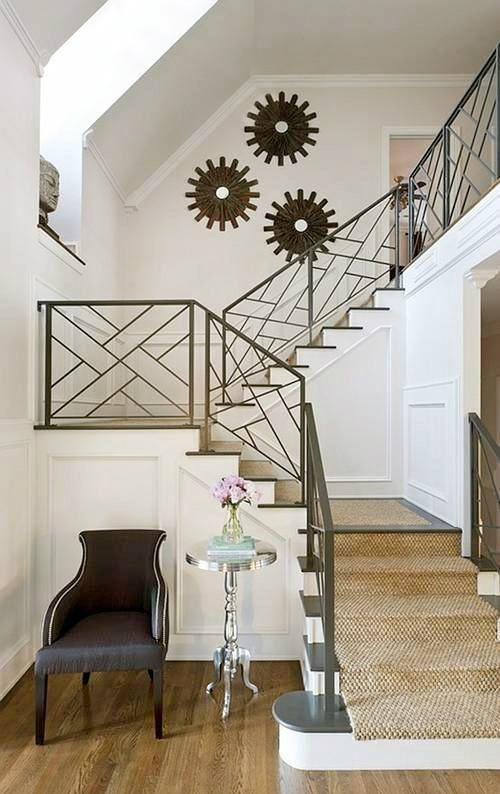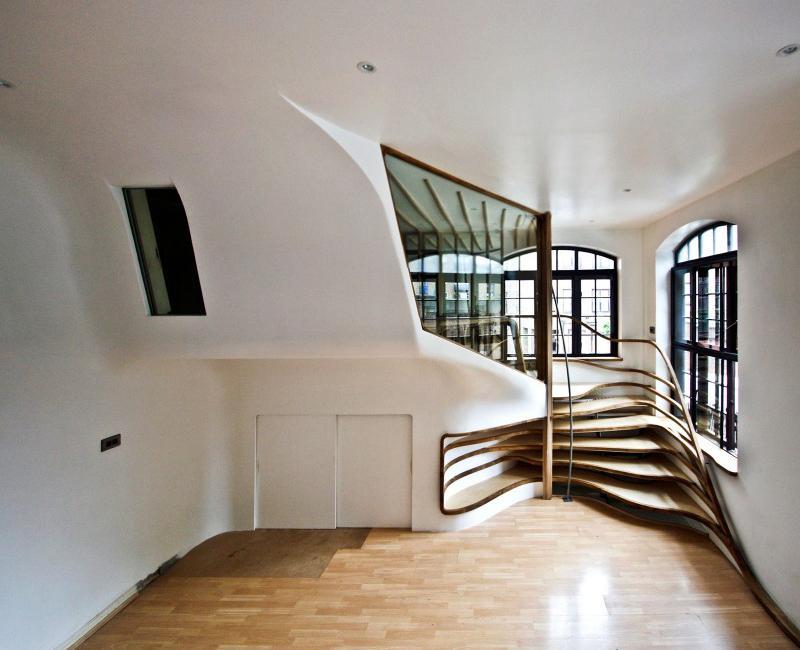The first image is the image on the left, the second image is the image on the right. For the images shown, is this caption "At least one of the lights is a pendant-style light hanging from the ceiling." true? Answer yes or no. No. 